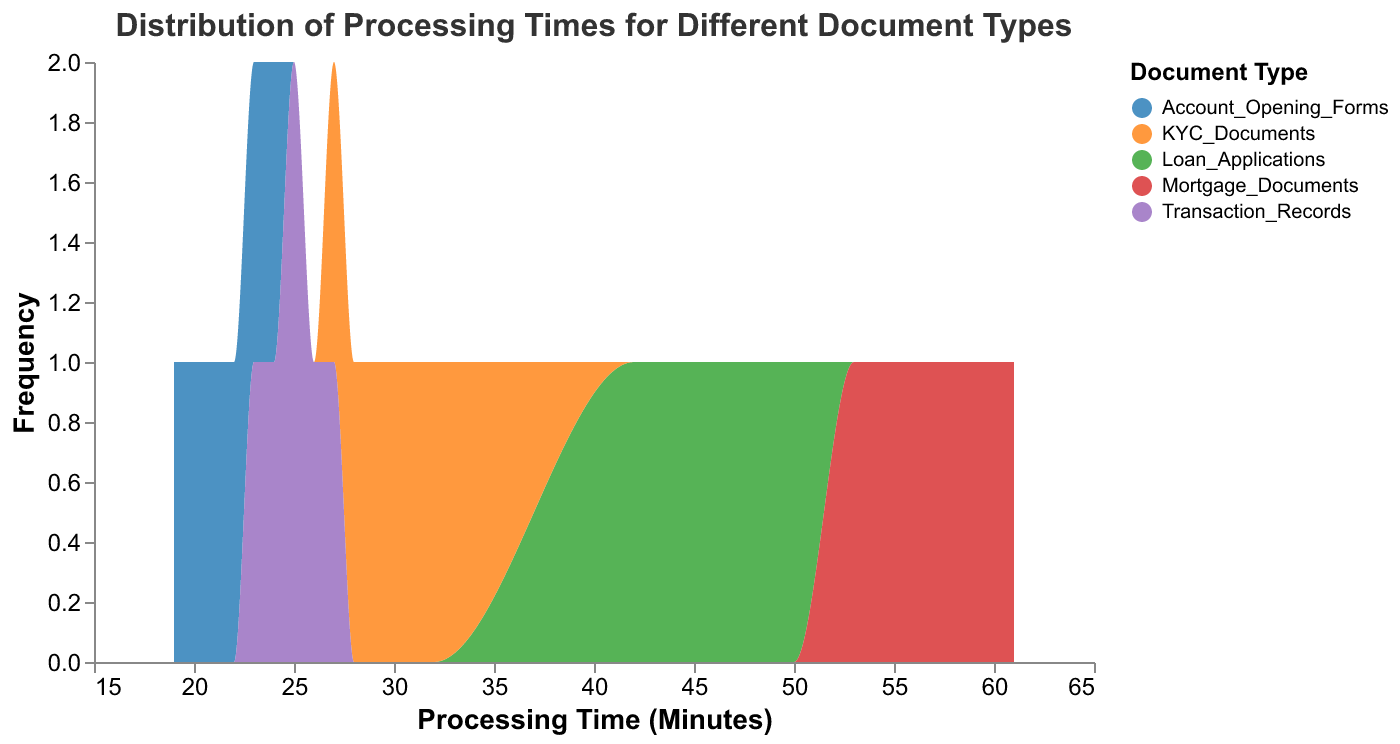What is the title of the plot? The title is typically located at the top of the figure. Here, it states, "Distribution of Processing Times for Different Document Types".
Answer: Distribution of Processing Times for Different Document Types Which document type has the highest average processing time? To find the average processing time for each document type, we sum the processing times and divide by the number of instances for each type. Mortgage Documents: (55+60+57+53+58+61)/6 = 57.33, Loan Applications: (45+50+42+47+49+46)/6 = 46.5, KYC Documents: (30+28+32+29+31+27)/6 = 29.5, Transaction Records: (25+26+24+23+27+25)/6 = 25, Account Opening Forms: (20+22+19+21+23+24)/6 = 21.5. The highest average is for Mortgage Documents at 57.33 minutes.
Answer: Mortgage Documents What is the common range of processing times for Loan Applications? By observing the x-axis range for Loan Applications, which typically appears as a curve on the plot, we note it spans from 42 to 50 minutes.
Answer: 42 to 50 minutes Which document type shows the most variability in processing times? Variability can be assessed by observing the spread of the distribution. Mortgage Documents show a broad range from about 53 to 61 minutes, indicating higher variability.
Answer: Mortgage Documents How does the frequency of processing times for Account Opening Forms compare to KYC Documents? By examining the y-axis (frequency) for both document types, the heights of the area under the curve indicate the count. Account Opening Forms show more tightly packed values around 19 to 24 minutes, with higher peak frequencies compared to the more dispersed KYC Documents spread between 27 to 32 minutes.
Answer: Account Opening Forms have higher peak frequency What is the mode of processing times for Transaction Records? The mode is the value that appears most frequently. In the distplot, it corresponds to the peak of the distribution curve for Transaction Records. The peak is at 25 minutes.
Answer: 25 minutes Which two document types have overlapping ranges of processing times? By analyzing the x-axis range where the distributions intersect, both KYC Documents (27 to 32 minutes) and Transaction Records (23 to 27 minutes) overlap roughly between 27 minutes.
Answer: KYC Documents and Transaction Records Which document type has the least amount of data points in the plot? Count the intervals (ticks) under each distribution. Mortgage Documents, Loan Applications, Account Opening Forms, KYC Documents, and Transaction Records appear equally represented given their distributions. Thus, all categories have the same number of data points, which is 6 each.
Answer: All document types have equal data points What can be inferred about the efficiency of processing different document types? The wider the range and the higher the average processing time, the less efficient the process. Mortgage Documents are less efficient due to higher average and variability, while Account Opening Forms are processed more efficiently due to low variability and lower average.
Answer: Mortgage Documents are less efficient, Account Opening Forms are more efficient 